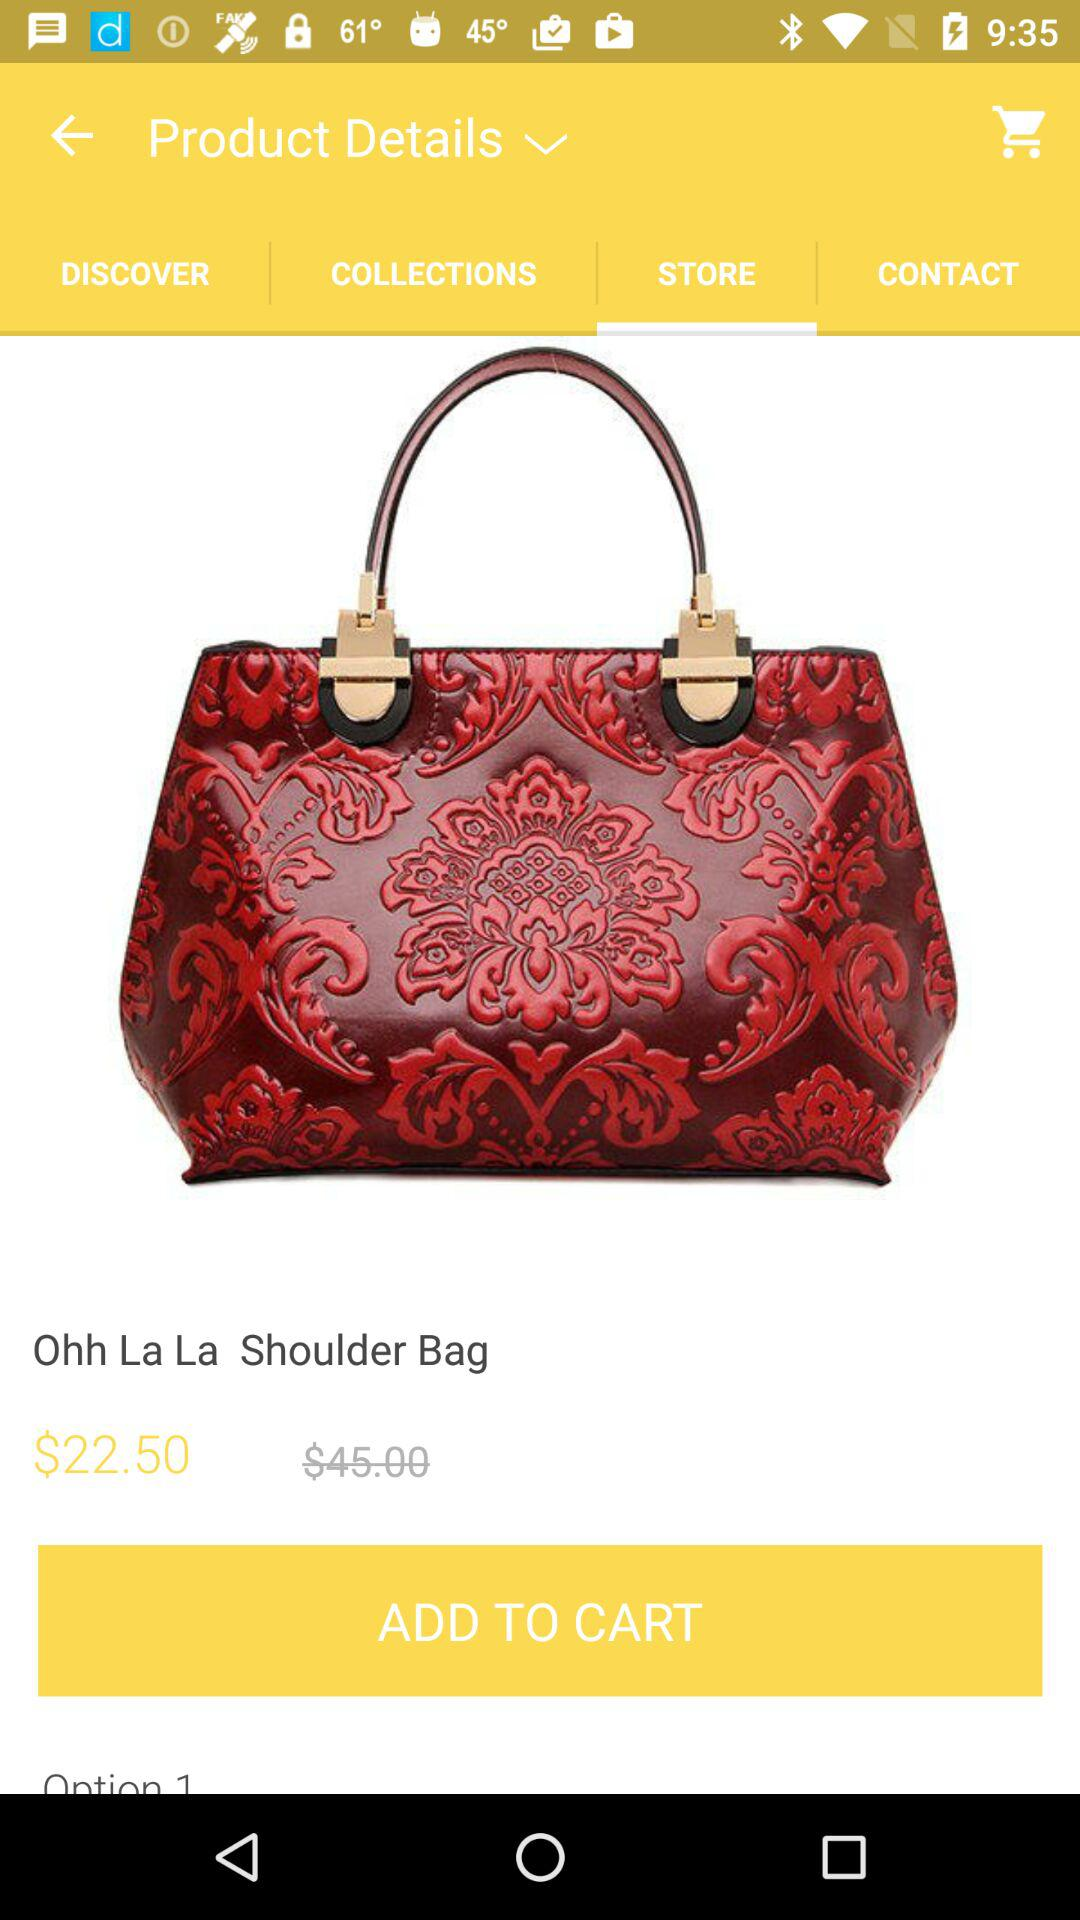What is the price difference between the two options?
Answer the question using a single word or phrase. $22.50 